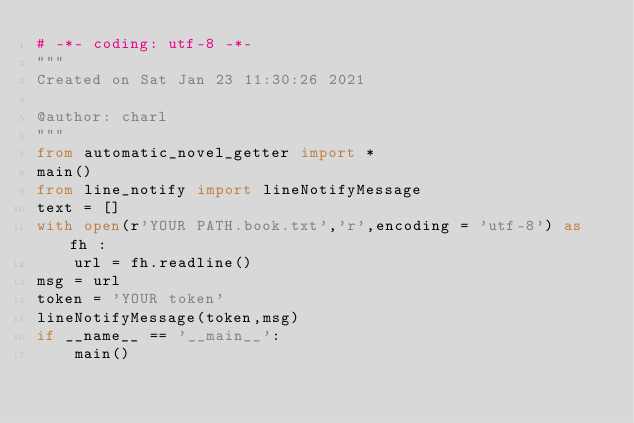Convert code to text. <code><loc_0><loc_0><loc_500><loc_500><_Python_># -*- coding: utf-8 -*-
"""
Created on Sat Jan 23 11:30:26 2021

@author: charl
"""
from automatic_novel_getter import *
main()
from line_notify import lineNotifyMessage
text = []
with open(r'YOUR PATH.book.txt','r',encoding = 'utf-8') as fh :
    url = fh.readline()
msg = url 
token = 'YOUR token'
lineNotifyMessage(token,msg)
if __name__ == '__main__':
    main()
        
</code> 